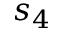Convert formula to latex. <formula><loc_0><loc_0><loc_500><loc_500>s _ { 4 }</formula> 